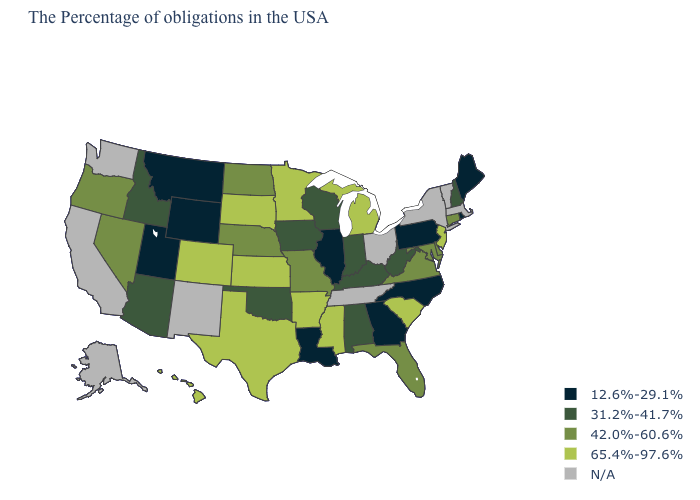Among the states that border West Virginia , does Virginia have the highest value?
Give a very brief answer. Yes. What is the value of New Jersey?
Concise answer only. 65.4%-97.6%. What is the value of Florida?
Write a very short answer. 42.0%-60.6%. What is the value of Alabama?
Keep it brief. 31.2%-41.7%. What is the value of Ohio?
Answer briefly. N/A. Does Pennsylvania have the highest value in the Northeast?
Be succinct. No. Among the states that border Texas , does Louisiana have the lowest value?
Quick response, please. Yes. What is the highest value in the South ?
Short answer required. 65.4%-97.6%. What is the lowest value in the South?
Be succinct. 12.6%-29.1%. Which states have the highest value in the USA?
Short answer required. New Jersey, South Carolina, Michigan, Mississippi, Arkansas, Minnesota, Kansas, Texas, South Dakota, Colorado, Hawaii. Which states have the lowest value in the South?
Keep it brief. North Carolina, Georgia, Louisiana. Does Maryland have the lowest value in the South?
Keep it brief. No. Among the states that border Missouri , which have the highest value?
Answer briefly. Arkansas, Kansas. What is the value of Montana?
Give a very brief answer. 12.6%-29.1%. What is the value of New Mexico?
Write a very short answer. N/A. 